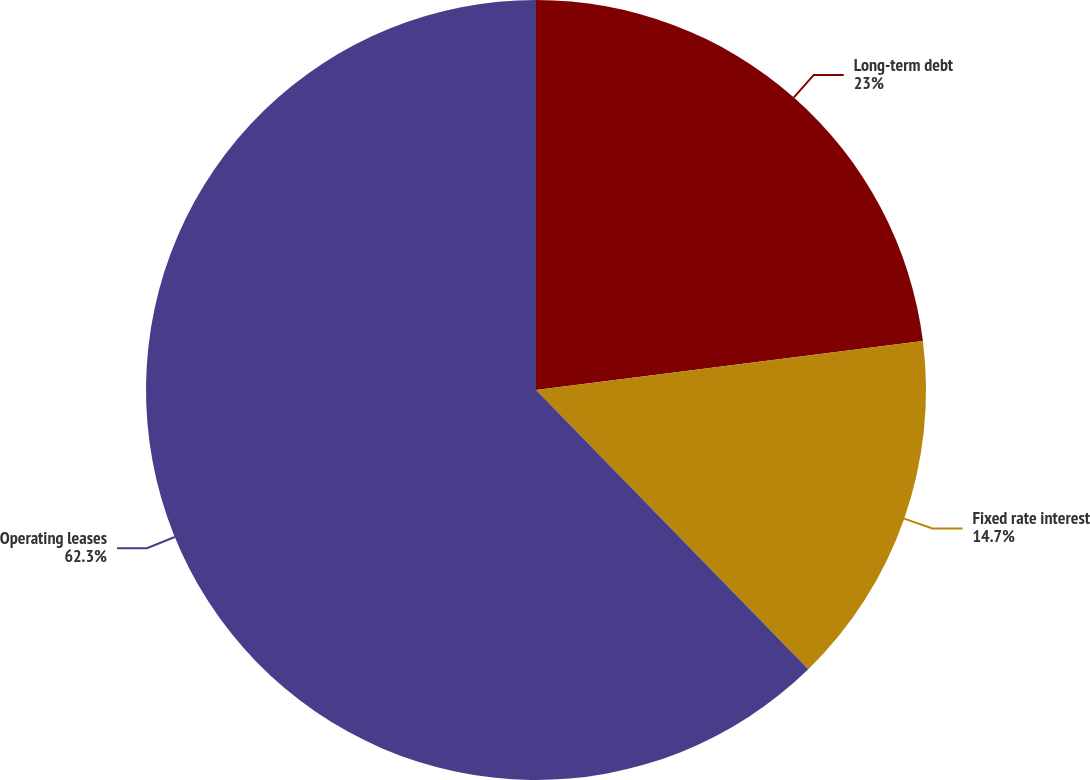Convert chart. <chart><loc_0><loc_0><loc_500><loc_500><pie_chart><fcel>Long-term debt<fcel>Fixed rate interest<fcel>Operating leases<nl><fcel>23.0%<fcel>14.7%<fcel>62.3%<nl></chart> 